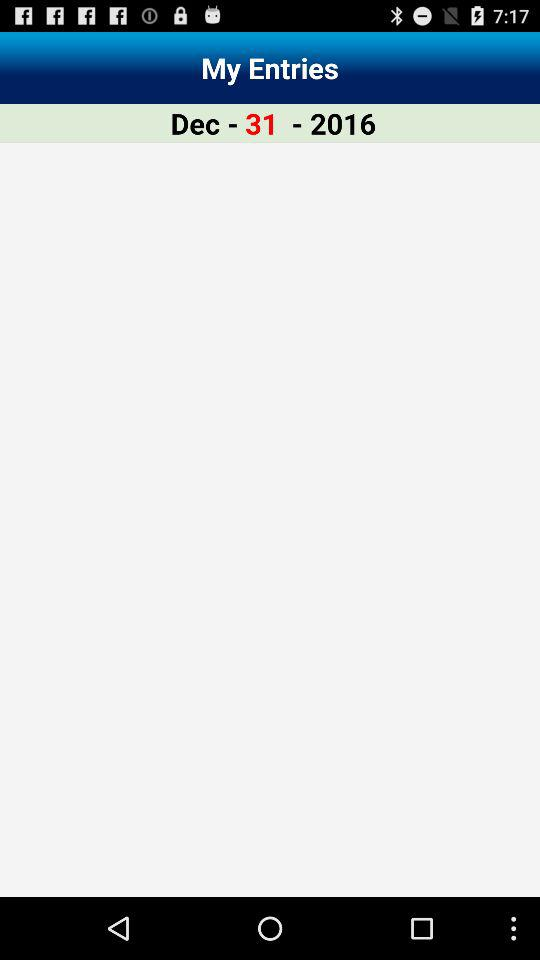What is the date selected to display entries? The date selected to display entries is December 31, 2016. 